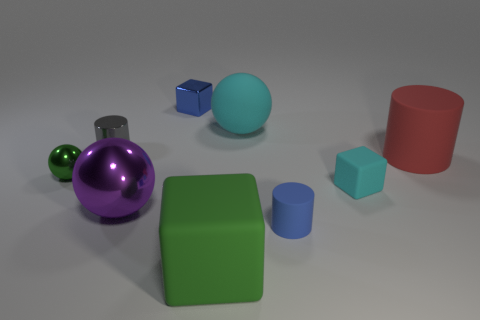What is the material of the object that is the same color as the large rubber sphere?
Ensure brevity in your answer.  Rubber. Do the large object behind the tiny metal cylinder and the tiny cube to the left of the green rubber cube have the same material?
Give a very brief answer. No. Is the number of tiny matte objects left of the purple object less than the number of small brown metal cylinders?
Provide a succinct answer. No. What color is the big object that is left of the large cube?
Your response must be concise. Purple. There is a cyan thing that is on the right side of the tiny blue rubber cylinder in front of the blue shiny object; what is it made of?
Your answer should be compact. Rubber. Are there any cyan rubber balls of the same size as the cyan block?
Offer a terse response. No. How many things are things that are on the left side of the small cyan cube or cyan things in front of the gray object?
Provide a short and direct response. 8. There is a sphere that is to the left of the gray cylinder; is its size the same as the ball that is to the right of the purple shiny ball?
Provide a short and direct response. No. There is a rubber ball behind the gray metallic cylinder; are there any green blocks in front of it?
Make the answer very short. Yes. There is a gray cylinder; what number of tiny gray shiny objects are behind it?
Provide a succinct answer. 0. 